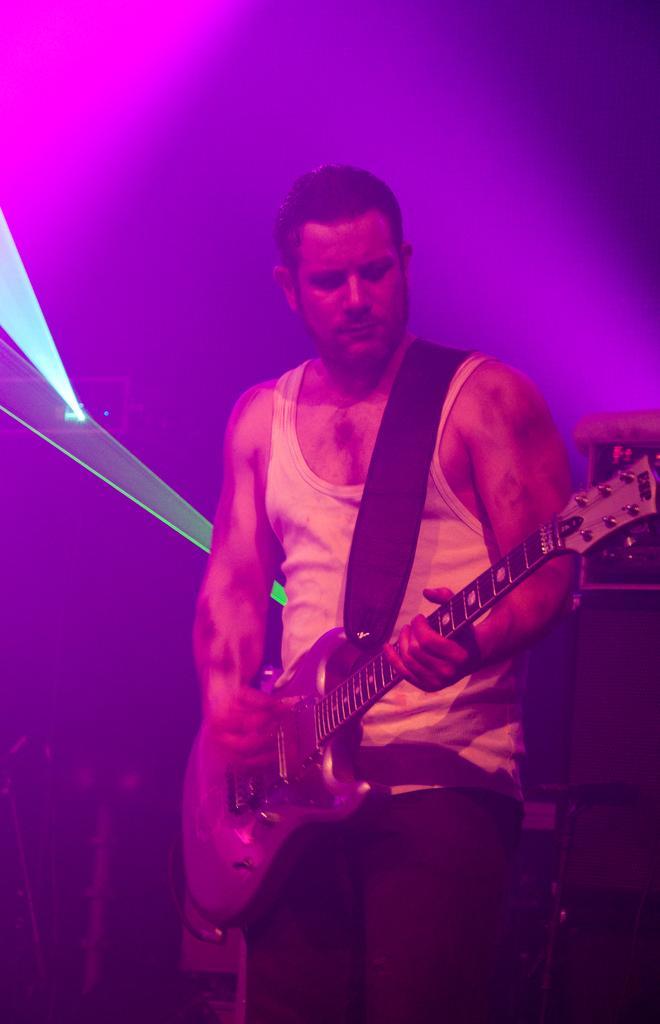In one or two sentences, can you explain what this image depicts? In this picture there is a man who is wearing t-shirt and trouser. He is playing a guitar. He is standing on the stage. Besides him there is a speaker. On the left there is a focus light. 